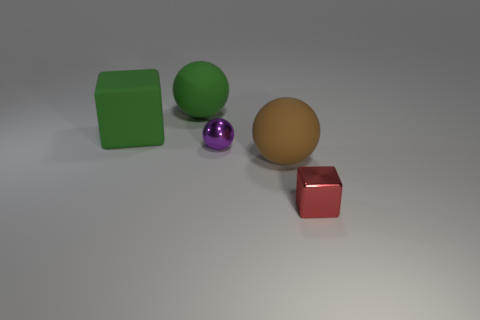Add 5 brown rubber things. How many objects exist? 10 Subtract all spheres. How many objects are left? 2 Subtract all small blue blocks. Subtract all large green spheres. How many objects are left? 4 Add 5 purple balls. How many purple balls are left? 6 Add 3 large purple matte spheres. How many large purple matte spheres exist? 3 Subtract 1 green blocks. How many objects are left? 4 